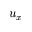<formula> <loc_0><loc_0><loc_500><loc_500>u _ { x }</formula> 